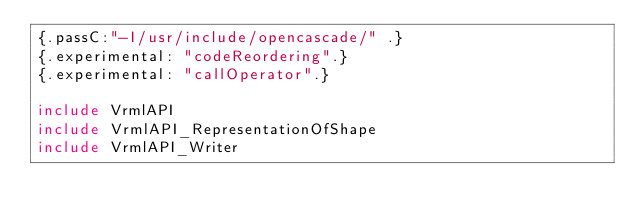Convert code to text. <code><loc_0><loc_0><loc_500><loc_500><_Nim_>{.passC:"-I/usr/include/opencascade/" .}
{.experimental: "codeReordering".}
{.experimental: "callOperator".}

include VrmlAPI
include VrmlAPI_RepresentationOfShape
include VrmlAPI_Writer


























</code> 